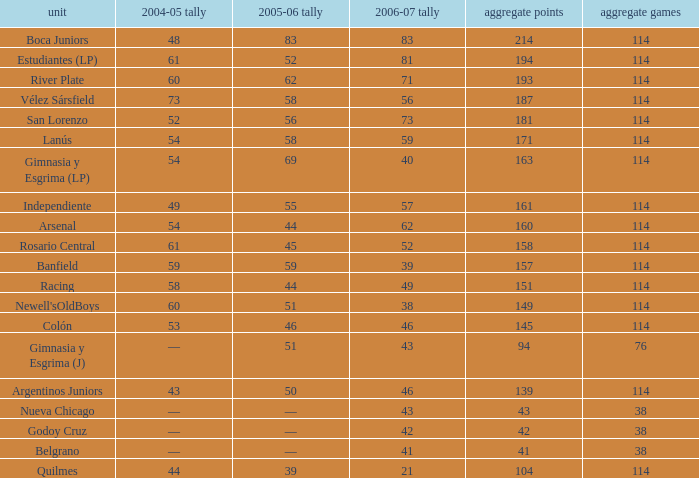What is the complete pld having 158 points in 2006-07, and lesser than 52 points in 2006-07? None. 